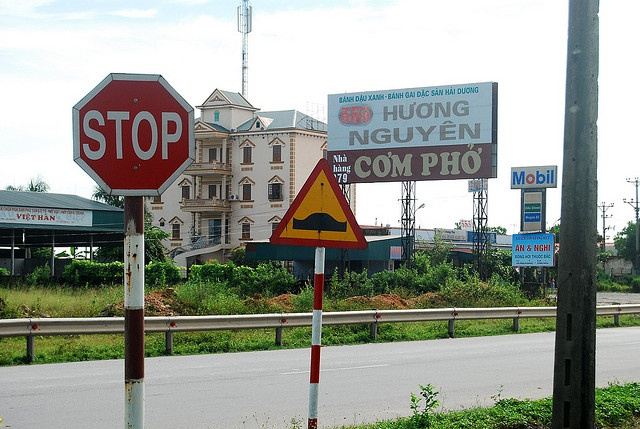Describe the objects in this image and their specific colors. I can see a stop sign in white, maroon, and gray tones in this image. 